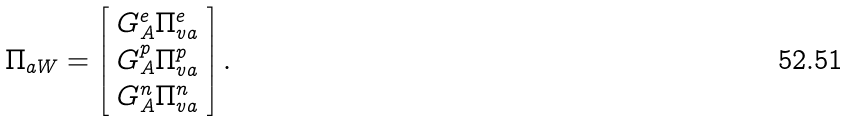Convert formula to latex. <formula><loc_0><loc_0><loc_500><loc_500>\Pi _ { a W } = \left [ \begin{array} { c } G _ { A } ^ { e } \Pi _ { v a } ^ { e } \\ G _ { A } ^ { p } \Pi _ { v a } ^ { p } \\ G _ { A } ^ { n } \Pi _ { v a } ^ { n } \end{array} \right ] .</formula> 